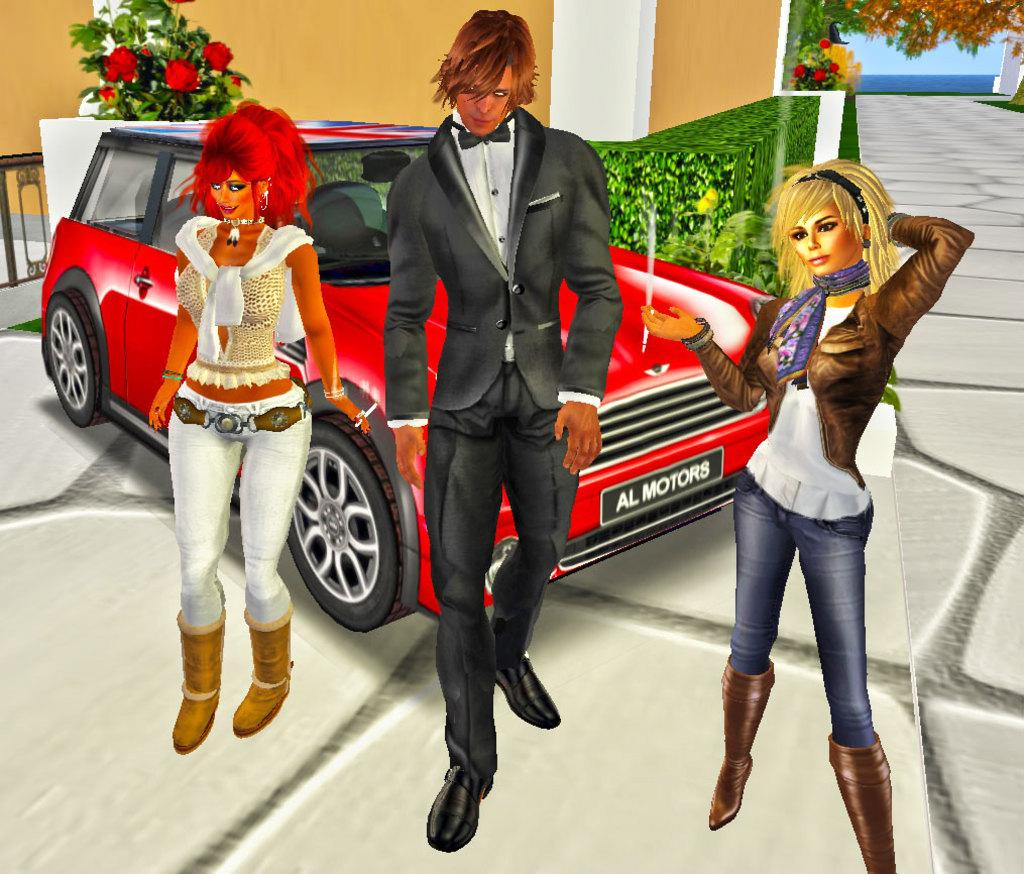What type of image is shown in the picture? The image contains a graphical picture. How many people are present in the image? There are three persons in the picture. What color is the car in the image? There is a red color car in the picture. What is the background of the image? There is a wall in the picture, along with bushes and flowers. What type of iron is being used by the persons in the image? There is no iron present in the image, and the persons are not using any iron-related objects. 